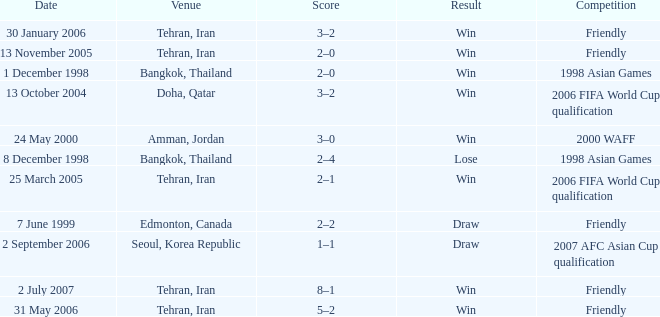On november 13, 2005, which competition occurred? Friendly. 